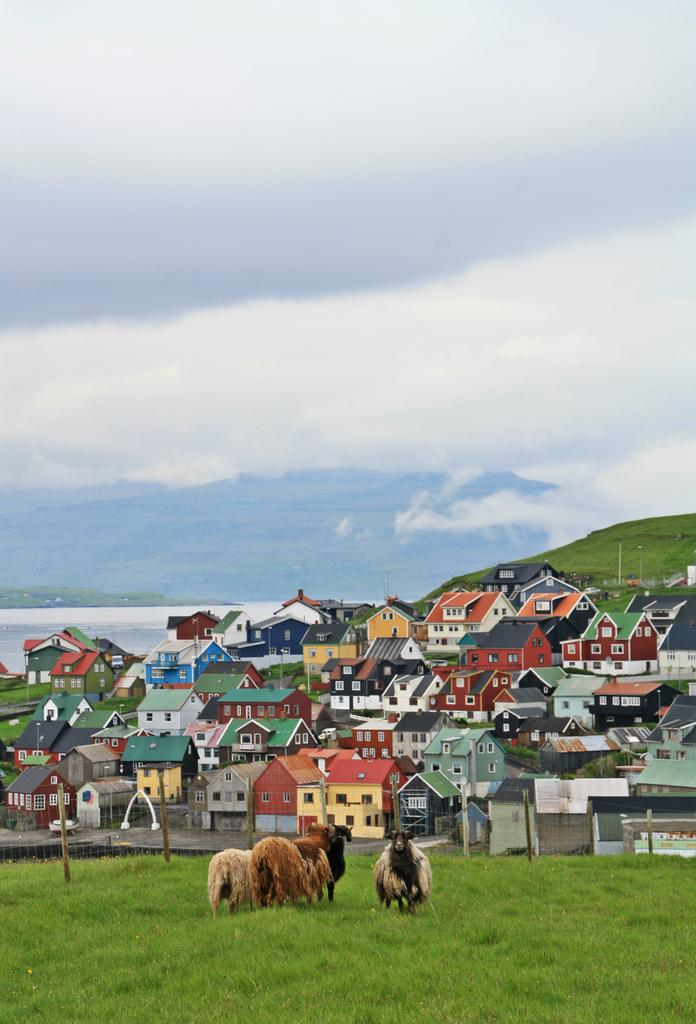What is located at the bottom of the image? There are houses, poles, a mesh, grass, and animals at the bottom of the image. What can be seen in the background of the image? There is water, a hill, and a cloudy sky visible in the background of the image. Can you tell me where the stranger is standing in the image? There is no stranger present in the image. What type of food is being cooked in the oven in the image? There is no oven present in the image. 